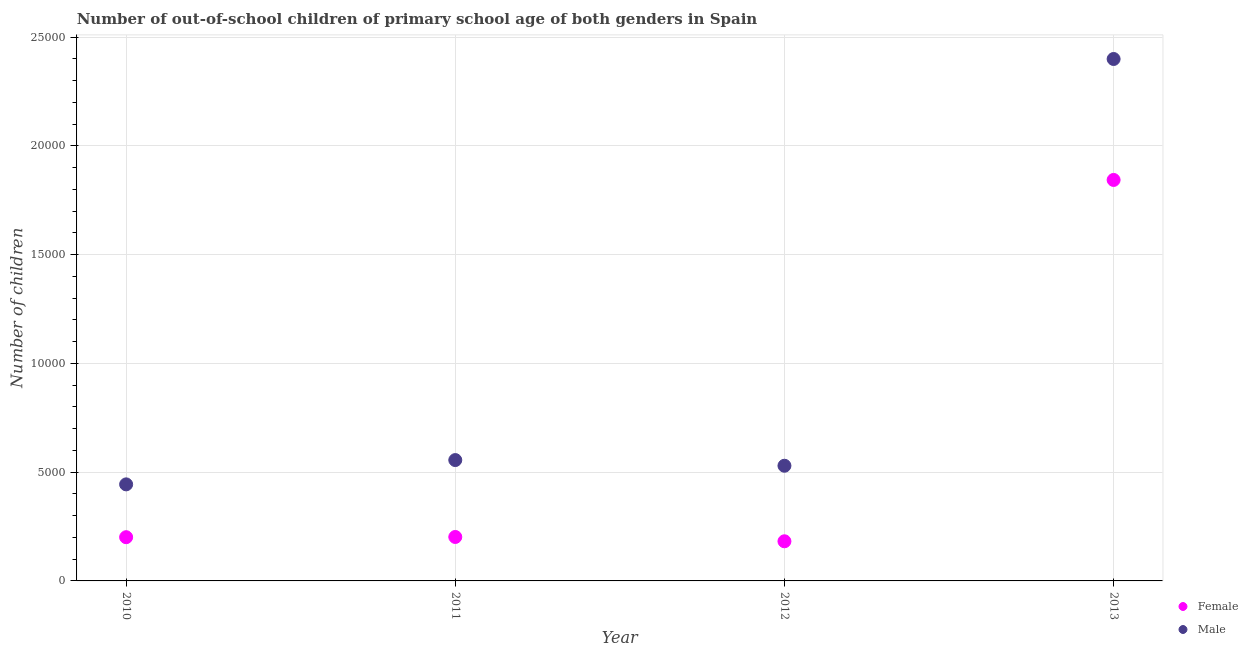How many different coloured dotlines are there?
Offer a terse response. 2. What is the number of male out-of-school students in 2010?
Make the answer very short. 4438. Across all years, what is the maximum number of male out-of-school students?
Offer a very short reply. 2.40e+04. Across all years, what is the minimum number of female out-of-school students?
Offer a very short reply. 1822. What is the total number of female out-of-school students in the graph?
Keep it short and to the point. 2.43e+04. What is the difference between the number of male out-of-school students in 2010 and that in 2013?
Offer a very short reply. -1.96e+04. What is the difference between the number of female out-of-school students in 2010 and the number of male out-of-school students in 2013?
Offer a very short reply. -2.20e+04. What is the average number of female out-of-school students per year?
Your answer should be compact. 6070.75. In the year 2012, what is the difference between the number of male out-of-school students and number of female out-of-school students?
Ensure brevity in your answer.  3472. In how many years, is the number of male out-of-school students greater than 14000?
Your answer should be very brief. 1. What is the ratio of the number of female out-of-school students in 2010 to that in 2011?
Provide a short and direct response. 1. Is the difference between the number of female out-of-school students in 2010 and 2012 greater than the difference between the number of male out-of-school students in 2010 and 2012?
Provide a short and direct response. Yes. What is the difference between the highest and the second highest number of male out-of-school students?
Make the answer very short. 1.84e+04. What is the difference between the highest and the lowest number of male out-of-school students?
Make the answer very short. 1.96e+04. Does the number of male out-of-school students monotonically increase over the years?
Provide a short and direct response. No. Is the number of female out-of-school students strictly greater than the number of male out-of-school students over the years?
Ensure brevity in your answer.  No. How many dotlines are there?
Your answer should be compact. 2. How many years are there in the graph?
Ensure brevity in your answer.  4. Are the values on the major ticks of Y-axis written in scientific E-notation?
Make the answer very short. No. Where does the legend appear in the graph?
Offer a very short reply. Bottom right. What is the title of the graph?
Provide a succinct answer. Number of out-of-school children of primary school age of both genders in Spain. Does "GDP per capita" appear as one of the legend labels in the graph?
Provide a succinct answer. No. What is the label or title of the X-axis?
Your response must be concise. Year. What is the label or title of the Y-axis?
Keep it short and to the point. Number of children. What is the Number of children of Female in 2010?
Offer a very short reply. 2010. What is the Number of children in Male in 2010?
Your response must be concise. 4438. What is the Number of children in Female in 2011?
Offer a very short reply. 2020. What is the Number of children in Male in 2011?
Provide a succinct answer. 5555. What is the Number of children in Female in 2012?
Your answer should be very brief. 1822. What is the Number of children of Male in 2012?
Your answer should be compact. 5294. What is the Number of children of Female in 2013?
Make the answer very short. 1.84e+04. What is the Number of children in Male in 2013?
Provide a short and direct response. 2.40e+04. Across all years, what is the maximum Number of children in Female?
Provide a short and direct response. 1.84e+04. Across all years, what is the maximum Number of children in Male?
Your answer should be very brief. 2.40e+04. Across all years, what is the minimum Number of children of Female?
Make the answer very short. 1822. Across all years, what is the minimum Number of children in Male?
Keep it short and to the point. 4438. What is the total Number of children of Female in the graph?
Provide a short and direct response. 2.43e+04. What is the total Number of children in Male in the graph?
Make the answer very short. 3.93e+04. What is the difference between the Number of children of Female in 2010 and that in 2011?
Offer a terse response. -10. What is the difference between the Number of children of Male in 2010 and that in 2011?
Provide a succinct answer. -1117. What is the difference between the Number of children in Female in 2010 and that in 2012?
Keep it short and to the point. 188. What is the difference between the Number of children in Male in 2010 and that in 2012?
Your answer should be compact. -856. What is the difference between the Number of children in Female in 2010 and that in 2013?
Your answer should be compact. -1.64e+04. What is the difference between the Number of children of Male in 2010 and that in 2013?
Ensure brevity in your answer.  -1.96e+04. What is the difference between the Number of children of Female in 2011 and that in 2012?
Offer a very short reply. 198. What is the difference between the Number of children in Male in 2011 and that in 2012?
Offer a very short reply. 261. What is the difference between the Number of children in Female in 2011 and that in 2013?
Make the answer very short. -1.64e+04. What is the difference between the Number of children in Male in 2011 and that in 2013?
Your answer should be very brief. -1.84e+04. What is the difference between the Number of children of Female in 2012 and that in 2013?
Your answer should be very brief. -1.66e+04. What is the difference between the Number of children in Male in 2012 and that in 2013?
Keep it short and to the point. -1.87e+04. What is the difference between the Number of children of Female in 2010 and the Number of children of Male in 2011?
Your answer should be compact. -3545. What is the difference between the Number of children in Female in 2010 and the Number of children in Male in 2012?
Keep it short and to the point. -3284. What is the difference between the Number of children in Female in 2010 and the Number of children in Male in 2013?
Offer a terse response. -2.20e+04. What is the difference between the Number of children of Female in 2011 and the Number of children of Male in 2012?
Your answer should be very brief. -3274. What is the difference between the Number of children of Female in 2011 and the Number of children of Male in 2013?
Offer a terse response. -2.20e+04. What is the difference between the Number of children of Female in 2012 and the Number of children of Male in 2013?
Offer a terse response. -2.22e+04. What is the average Number of children of Female per year?
Give a very brief answer. 6070.75. What is the average Number of children of Male per year?
Provide a succinct answer. 9819.5. In the year 2010, what is the difference between the Number of children of Female and Number of children of Male?
Provide a succinct answer. -2428. In the year 2011, what is the difference between the Number of children in Female and Number of children in Male?
Make the answer very short. -3535. In the year 2012, what is the difference between the Number of children in Female and Number of children in Male?
Provide a succinct answer. -3472. In the year 2013, what is the difference between the Number of children of Female and Number of children of Male?
Your answer should be compact. -5560. What is the ratio of the Number of children of Male in 2010 to that in 2011?
Your answer should be very brief. 0.8. What is the ratio of the Number of children of Female in 2010 to that in 2012?
Make the answer very short. 1.1. What is the ratio of the Number of children of Male in 2010 to that in 2012?
Your answer should be compact. 0.84. What is the ratio of the Number of children of Female in 2010 to that in 2013?
Give a very brief answer. 0.11. What is the ratio of the Number of children in Male in 2010 to that in 2013?
Offer a very short reply. 0.18. What is the ratio of the Number of children of Female in 2011 to that in 2012?
Offer a terse response. 1.11. What is the ratio of the Number of children of Male in 2011 to that in 2012?
Your answer should be compact. 1.05. What is the ratio of the Number of children in Female in 2011 to that in 2013?
Give a very brief answer. 0.11. What is the ratio of the Number of children of Male in 2011 to that in 2013?
Offer a terse response. 0.23. What is the ratio of the Number of children of Female in 2012 to that in 2013?
Ensure brevity in your answer.  0.1. What is the ratio of the Number of children of Male in 2012 to that in 2013?
Provide a succinct answer. 0.22. What is the difference between the highest and the second highest Number of children of Female?
Your answer should be very brief. 1.64e+04. What is the difference between the highest and the second highest Number of children in Male?
Give a very brief answer. 1.84e+04. What is the difference between the highest and the lowest Number of children in Female?
Offer a terse response. 1.66e+04. What is the difference between the highest and the lowest Number of children of Male?
Your answer should be compact. 1.96e+04. 